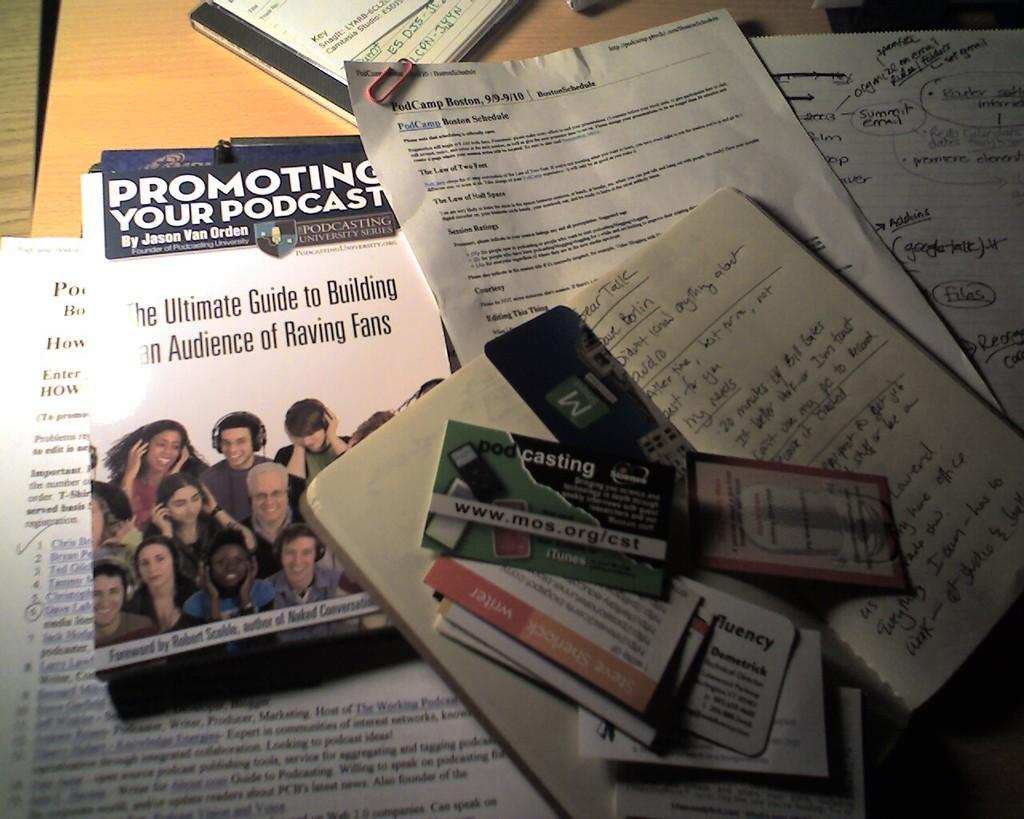<image>
Describe the image concisely. A bunch of pamphlets with one titled Promoting your Podcast. 